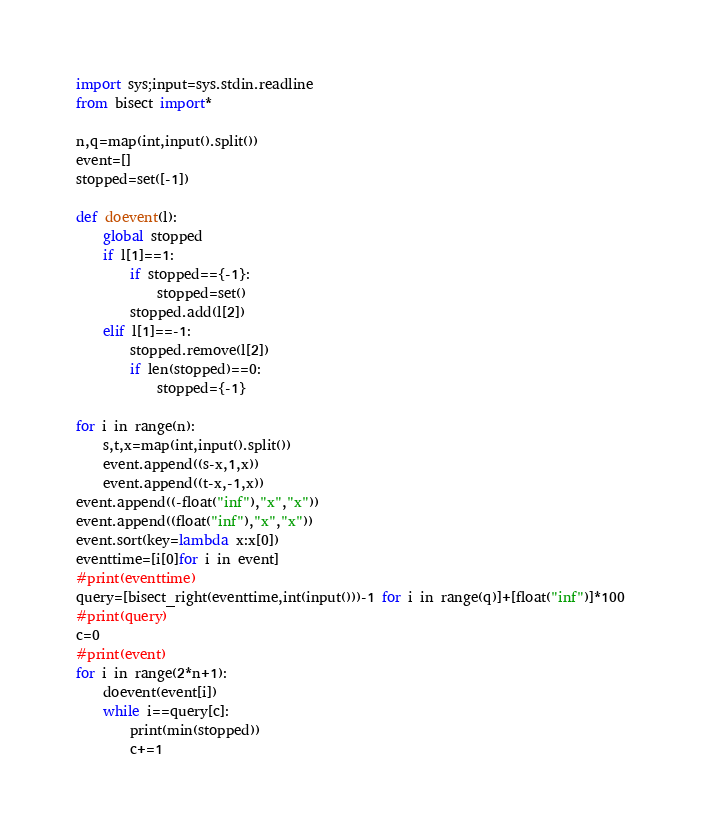<code> <loc_0><loc_0><loc_500><loc_500><_Python_>import sys;input=sys.stdin.readline
from bisect import*

n,q=map(int,input().split())
event=[]
stopped=set([-1])

def doevent(l):
    global stopped
    if l[1]==1:
        if stopped=={-1}:
            stopped=set()
        stopped.add(l[2])
    elif l[1]==-1:
        stopped.remove(l[2])
        if len(stopped)==0:
            stopped={-1}
            
for i in range(n):
    s,t,x=map(int,input().split())
    event.append((s-x,1,x))
    event.append((t-x,-1,x))
event.append((-float("inf"),"x","x"))
event.append((float("inf"),"x","x"))
event.sort(key=lambda x:x[0])
eventtime=[i[0]for i in event]
#print(eventtime)
query=[bisect_right(eventtime,int(input()))-1 for i in range(q)]+[float("inf")]*100
#print(query)
c=0
#print(event)
for i in range(2*n+1):
    doevent(event[i])
    while i==query[c]:
        print(min(stopped))
        c+=1</code> 